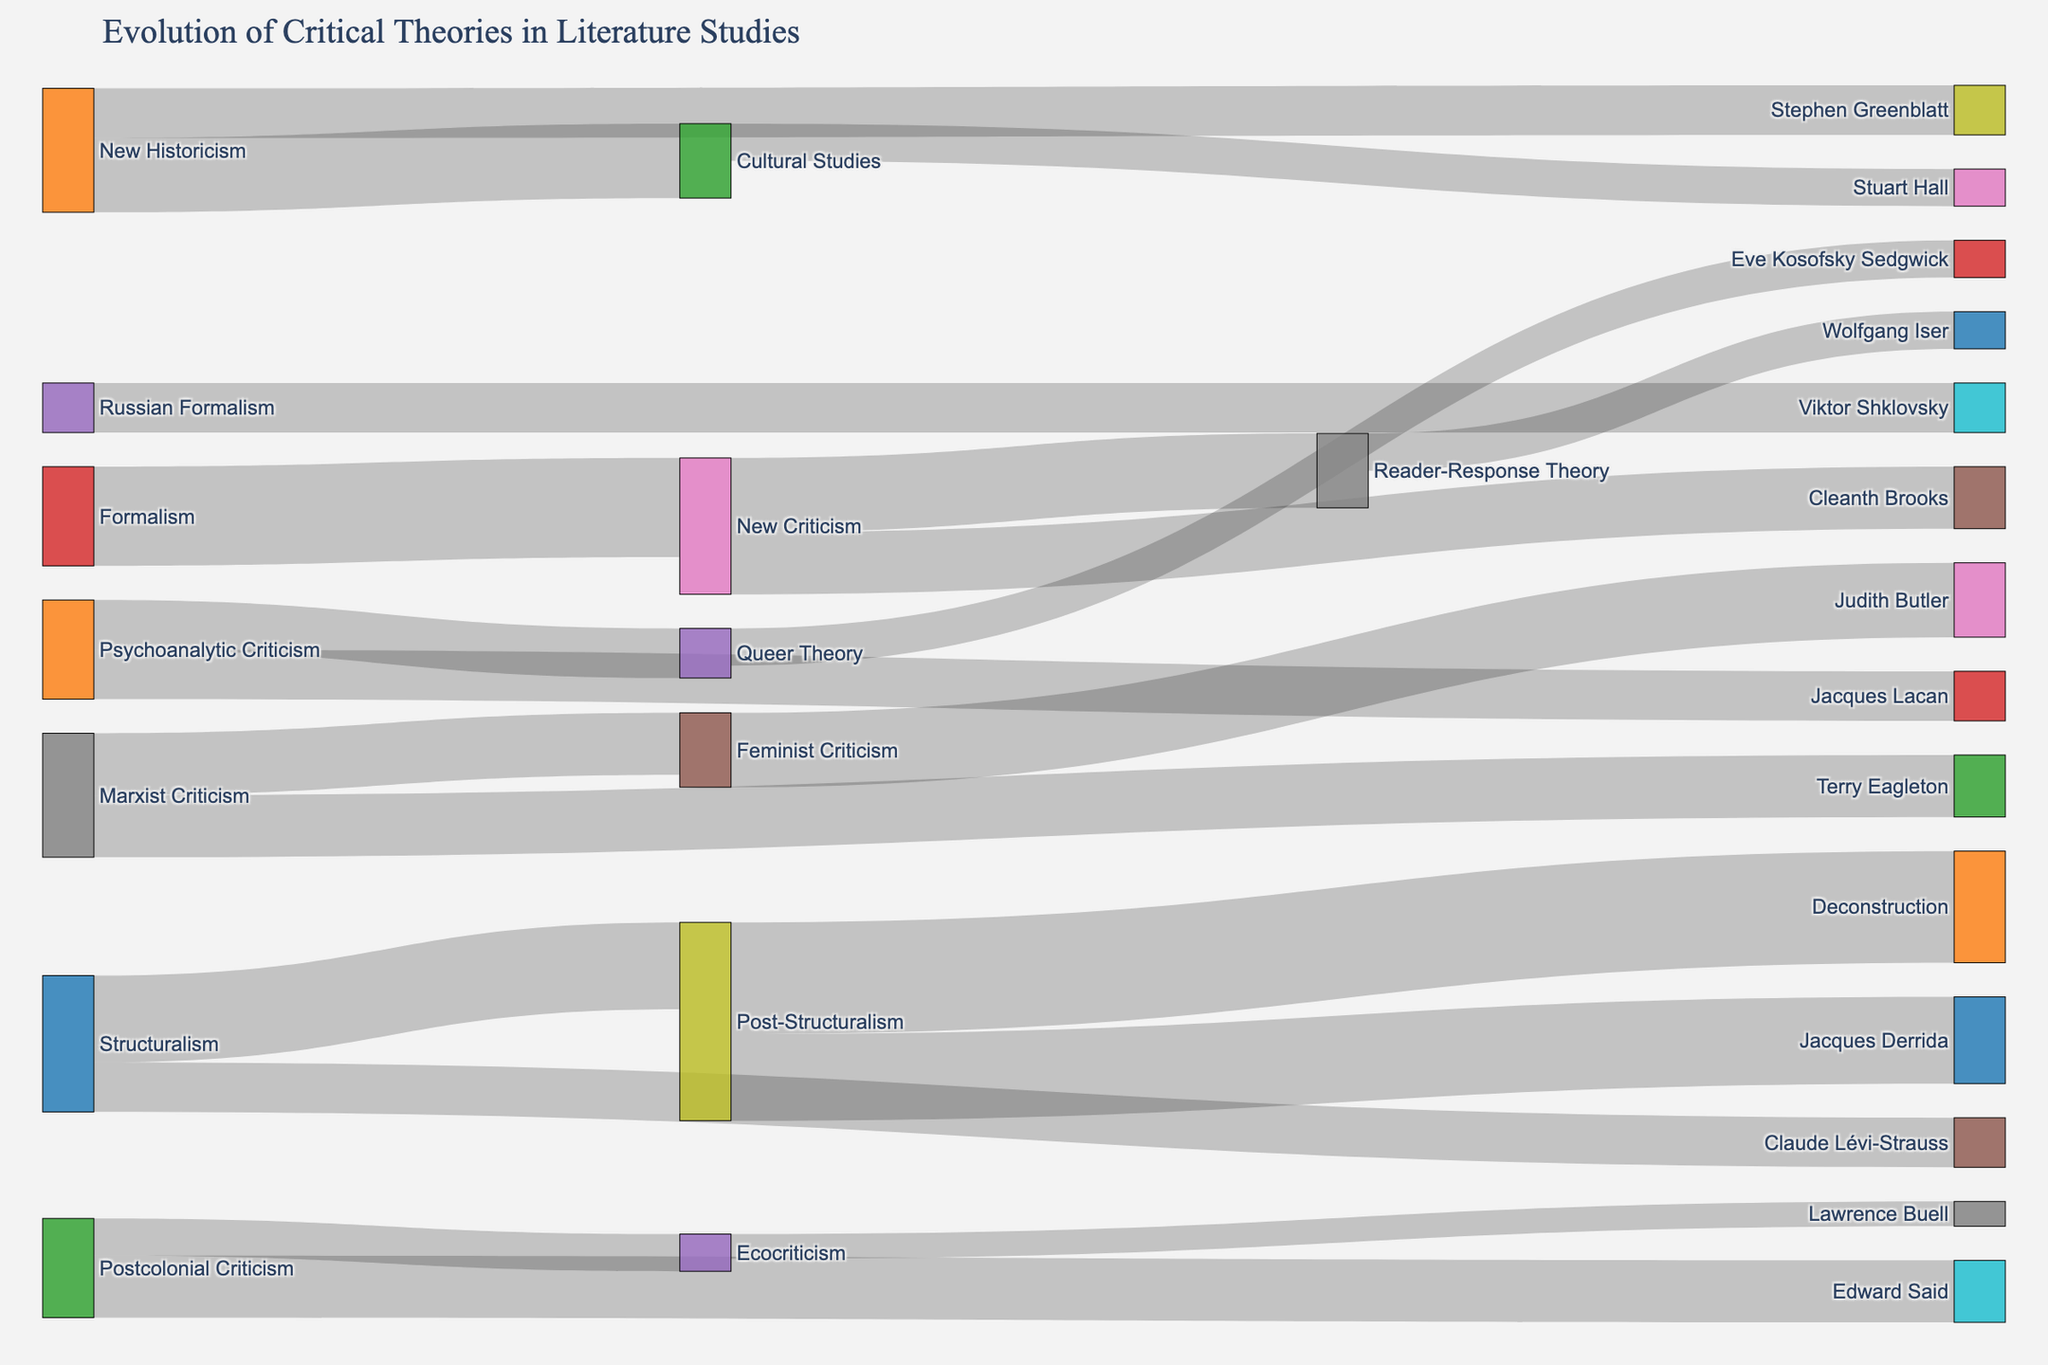How many connections originate from Post-Structuralism? First, locate Post-Structuralism in the diagram. Second, count the arrows originating from this node to other nodes. There are arrows going to Deconstruction and Jacques Derrida.
Answer: 2 Which theory has the highest value connection stemming from it? Review all the value connections from each theory. The highest value found is 9, which is the connection from Post-Structuralism to Deconstruction.
Answer: Post-Structuralism How many theorists are influenced by New Criticism? Identify the branches stemming from New Criticism leading to individual theorists. The diagram shows connections to Cleanth Brooks and Wolfgang Iser.
Answer: 2 Is the value of connections from New Historicism greater than from Cultural Studies? Sum the values of connections from New Historicism, which is New Historicism to Stephen Greenblatt (4) and New Historicism to Cultural Studies (6). The sum is 10. For Cultural Studies, the connection to Stuart Hall is valued at 3. Therefore, 10 is greater than 3.
Answer: Yes What is the total value of connections related to Marxist Criticism? Locate Marxist Criticism and sum its connections: Marxist Criticism to Feminist Criticism (5) and Marxist Criticism to Terry Eagleton (5). Adding these gives 5 + 5 = 10.
Answer: 10 Which theory is connected to Jacques Derrida? Find Jacques Derrida in the target nodes and follow the line back to the source. The connection originates from Post-Structuralism.
Answer: Post-Structuralism What is the average value of connections starting from Feminist Criticism? Identify connections from Feminist Criticism, which are to Judith Butler (6). Since there is only one connection, the average value is 6.
Answer: 6 Are there more connections originating from Formalism or Structuralism? Count the connections from Formalism, which is only to New Criticism (1), and count the connections from Structuralism: Post-Structuralism (7) and Claude Lévi-Strauss (4), totaling 2 connections.
Answer: Structuralism Which theory has a connection with the lowest value? Compare all connection values. The lowest value is 2, which maps from Ecocriticism to Lawrence Buell.
Answer: Ecocriticism Who is influenced by Psychoanalytic Criticism? Locate the connections from Psychoanalytic Criticism. The target nodes are Queer Theory (4) and Jacques Lacan (4).
Answer: Queer Theory, Jacques Lacan 